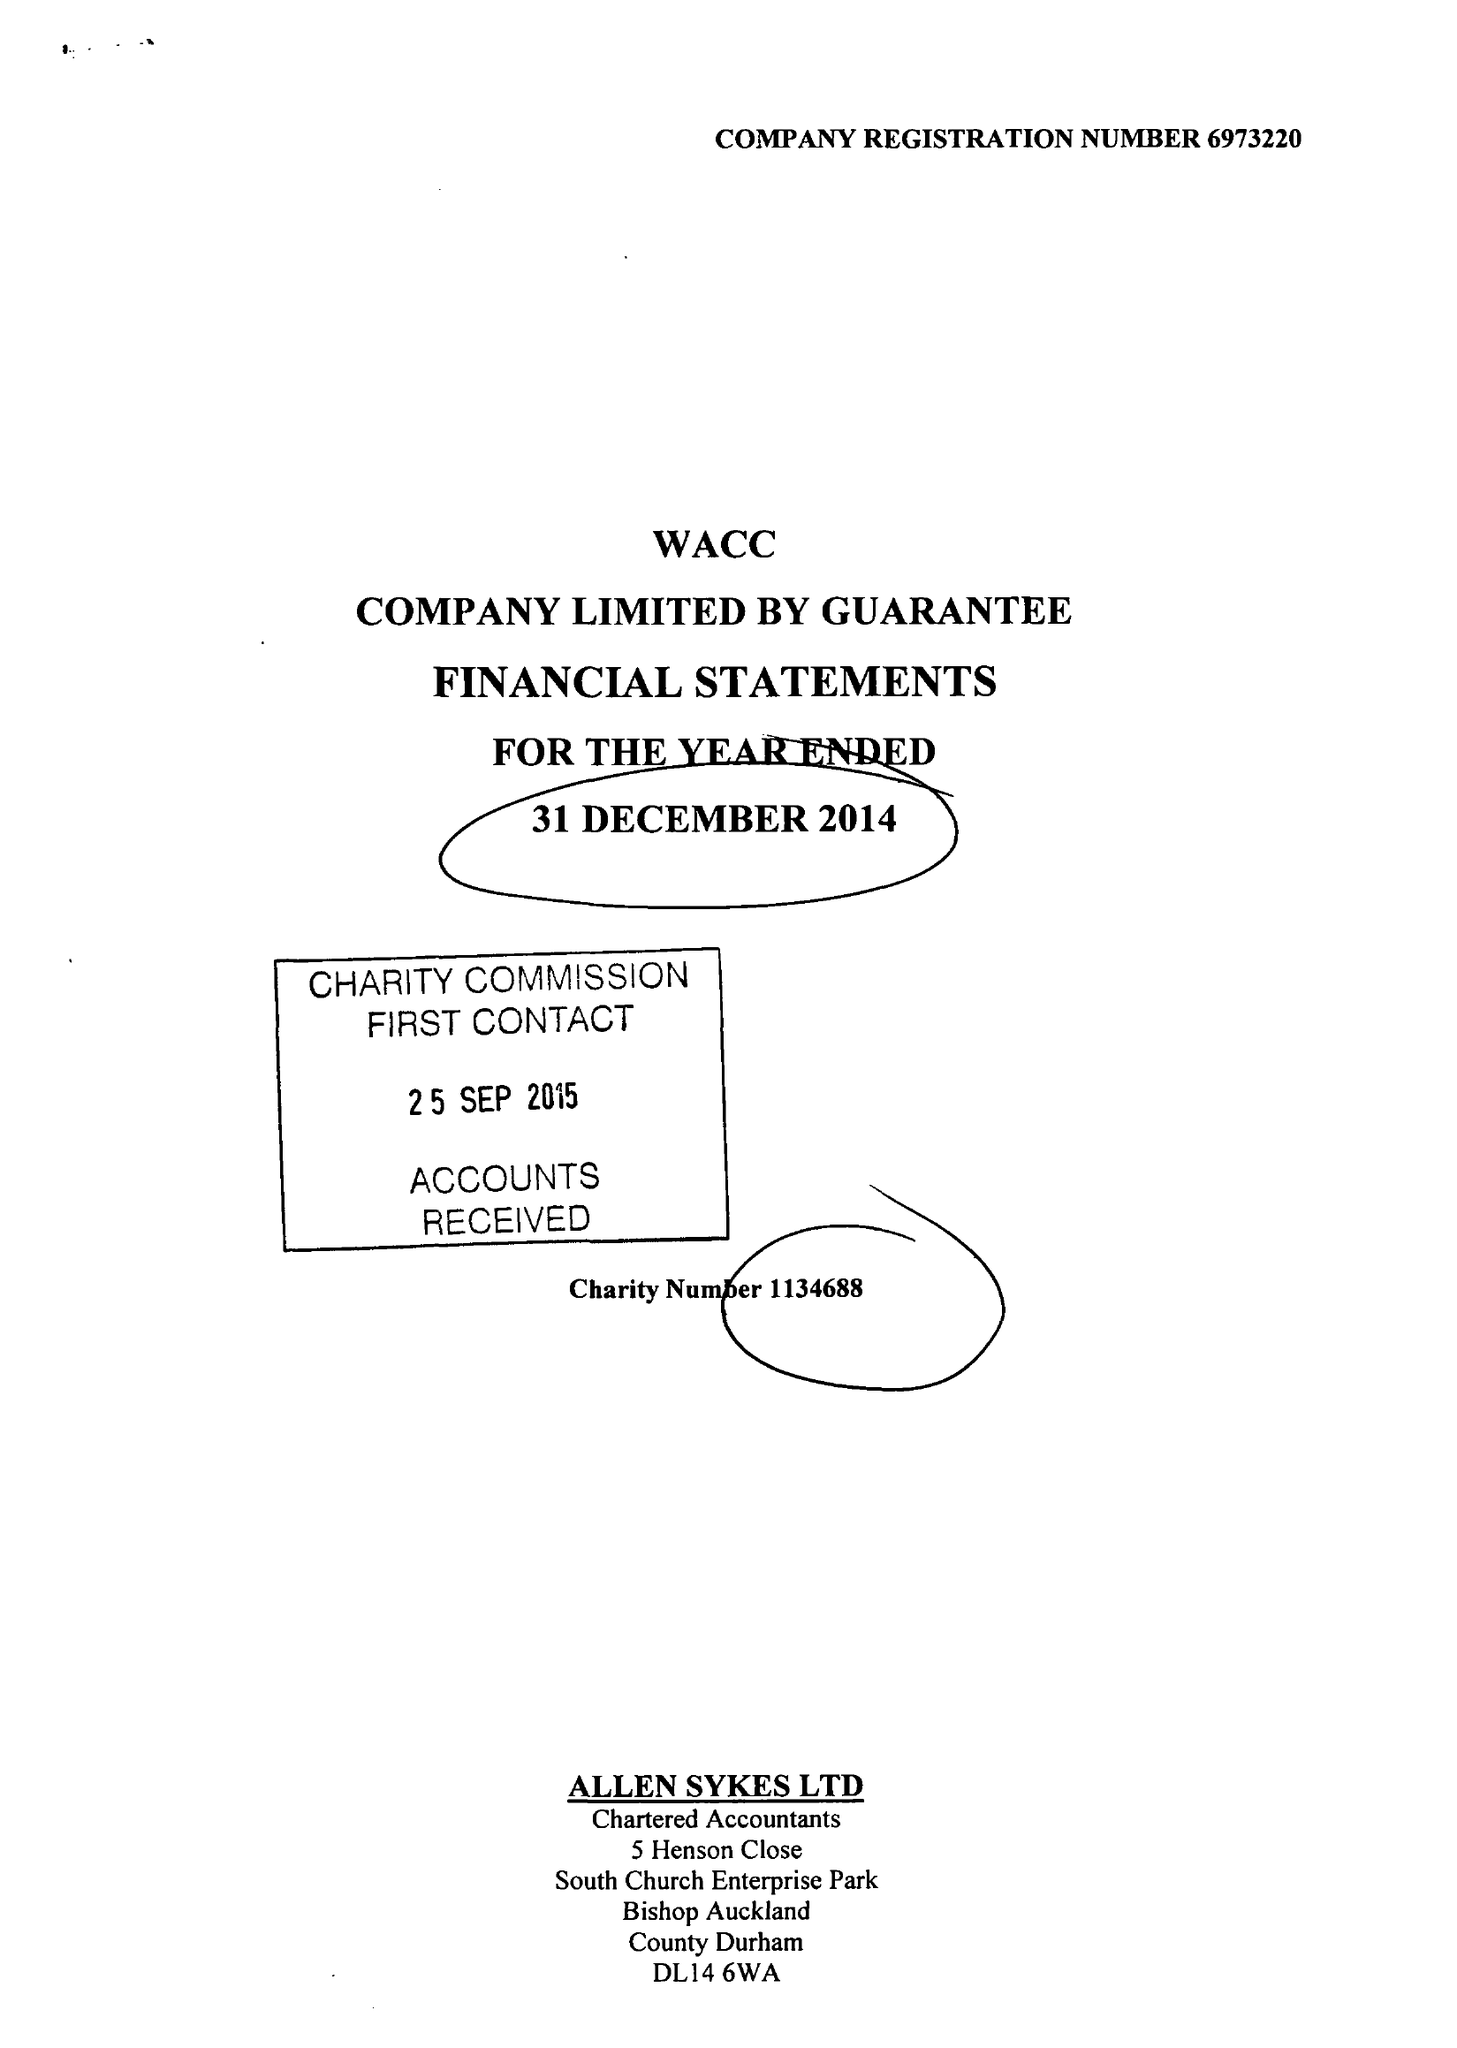What is the value for the report_date?
Answer the question using a single word or phrase. 2014-12-31 